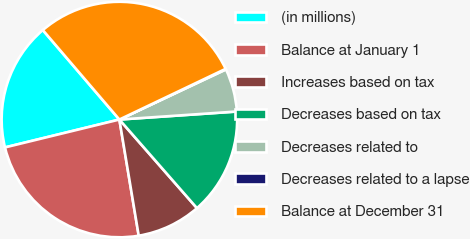<chart> <loc_0><loc_0><loc_500><loc_500><pie_chart><fcel>(in millions)<fcel>Balance at January 1<fcel>Increases based on tax<fcel>Decreases based on tax<fcel>Decreases related to<fcel>Decreases related to a lapse<fcel>Balance at December 31<nl><fcel>17.54%<fcel>23.82%<fcel>8.82%<fcel>14.64%<fcel>5.91%<fcel>0.09%<fcel>29.18%<nl></chart> 